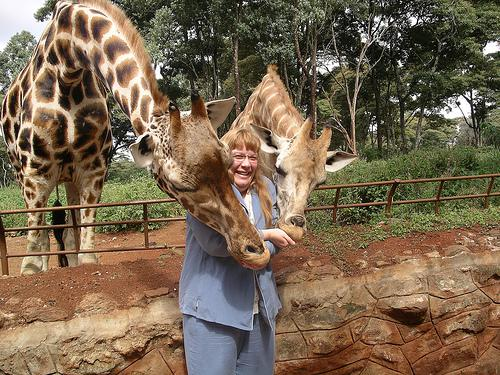Question: where was the picture taken?
Choices:
A. Wildlife refuge.
B. Farm.
C. At a zoo.
D. Park.
Answer with the letter. Answer: C Question: what color is the dirt?
Choices:
A. Brown.
B. Red.
C. Orange.
D. Black.
Answer with the letter. Answer: A Question: who is wearing glasses?
Choices:
A. The dog.
B. The boy.
C. Everyone.
D. The woman.
Answer with the letter. Answer: D Question: what color are the giraffes?
Choices:
A. Yellow and orange.
B. Red and blue.
C. Brown and white.
D. Pink and purple.
Answer with the letter. Answer: C Question: how many giraffes are there?
Choices:
A. 5.
B. 3.
C. 2.
D. 1.
Answer with the letter. Answer: C 